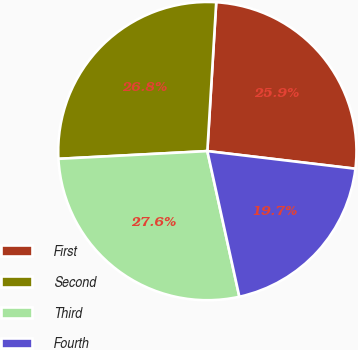Convert chart to OTSL. <chart><loc_0><loc_0><loc_500><loc_500><pie_chart><fcel>First<fcel>Second<fcel>Third<fcel>Fourth<nl><fcel>25.94%<fcel>26.78%<fcel>27.62%<fcel>19.67%<nl></chart> 